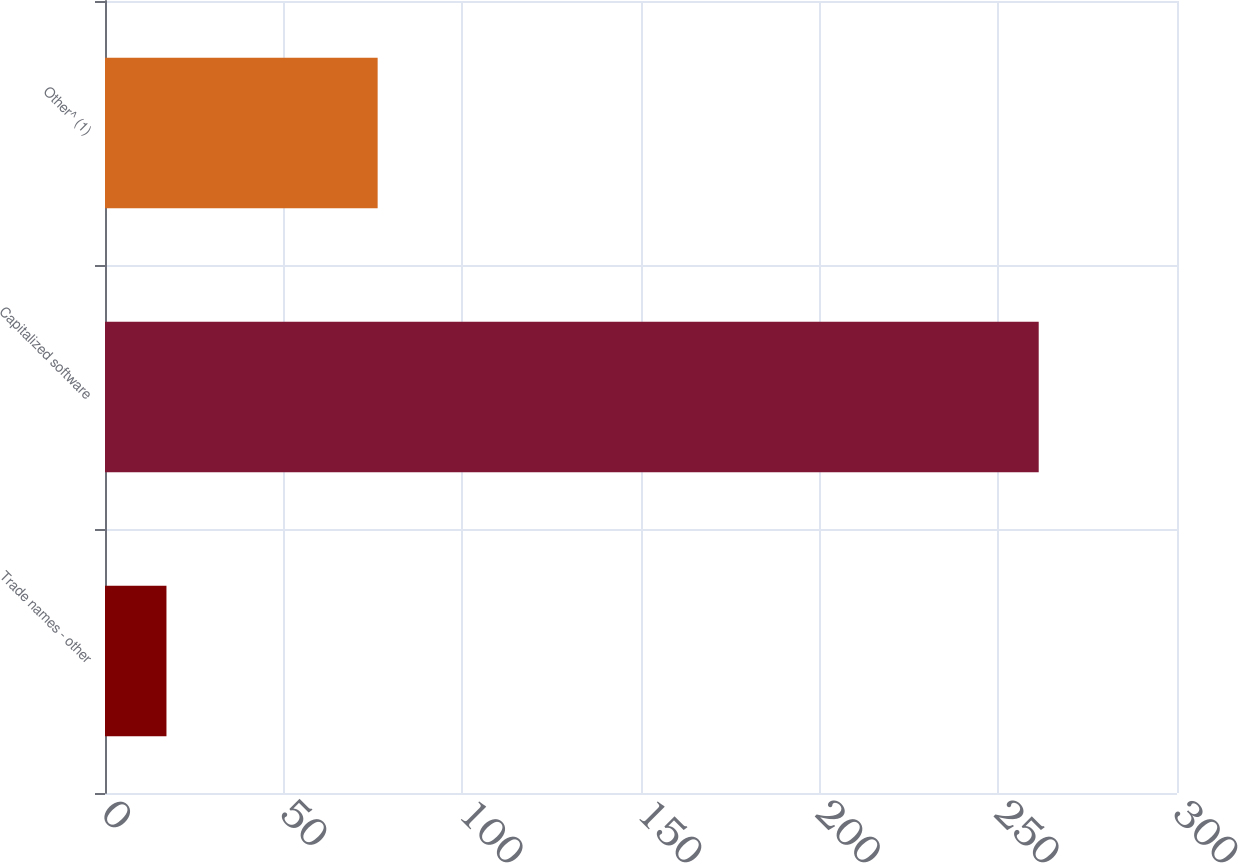Convert chart to OTSL. <chart><loc_0><loc_0><loc_500><loc_500><bar_chart><fcel>Trade names - other<fcel>Capitalized software<fcel>Other^ (1)<nl><fcel>17.2<fcel>261.3<fcel>76.3<nl></chart> 